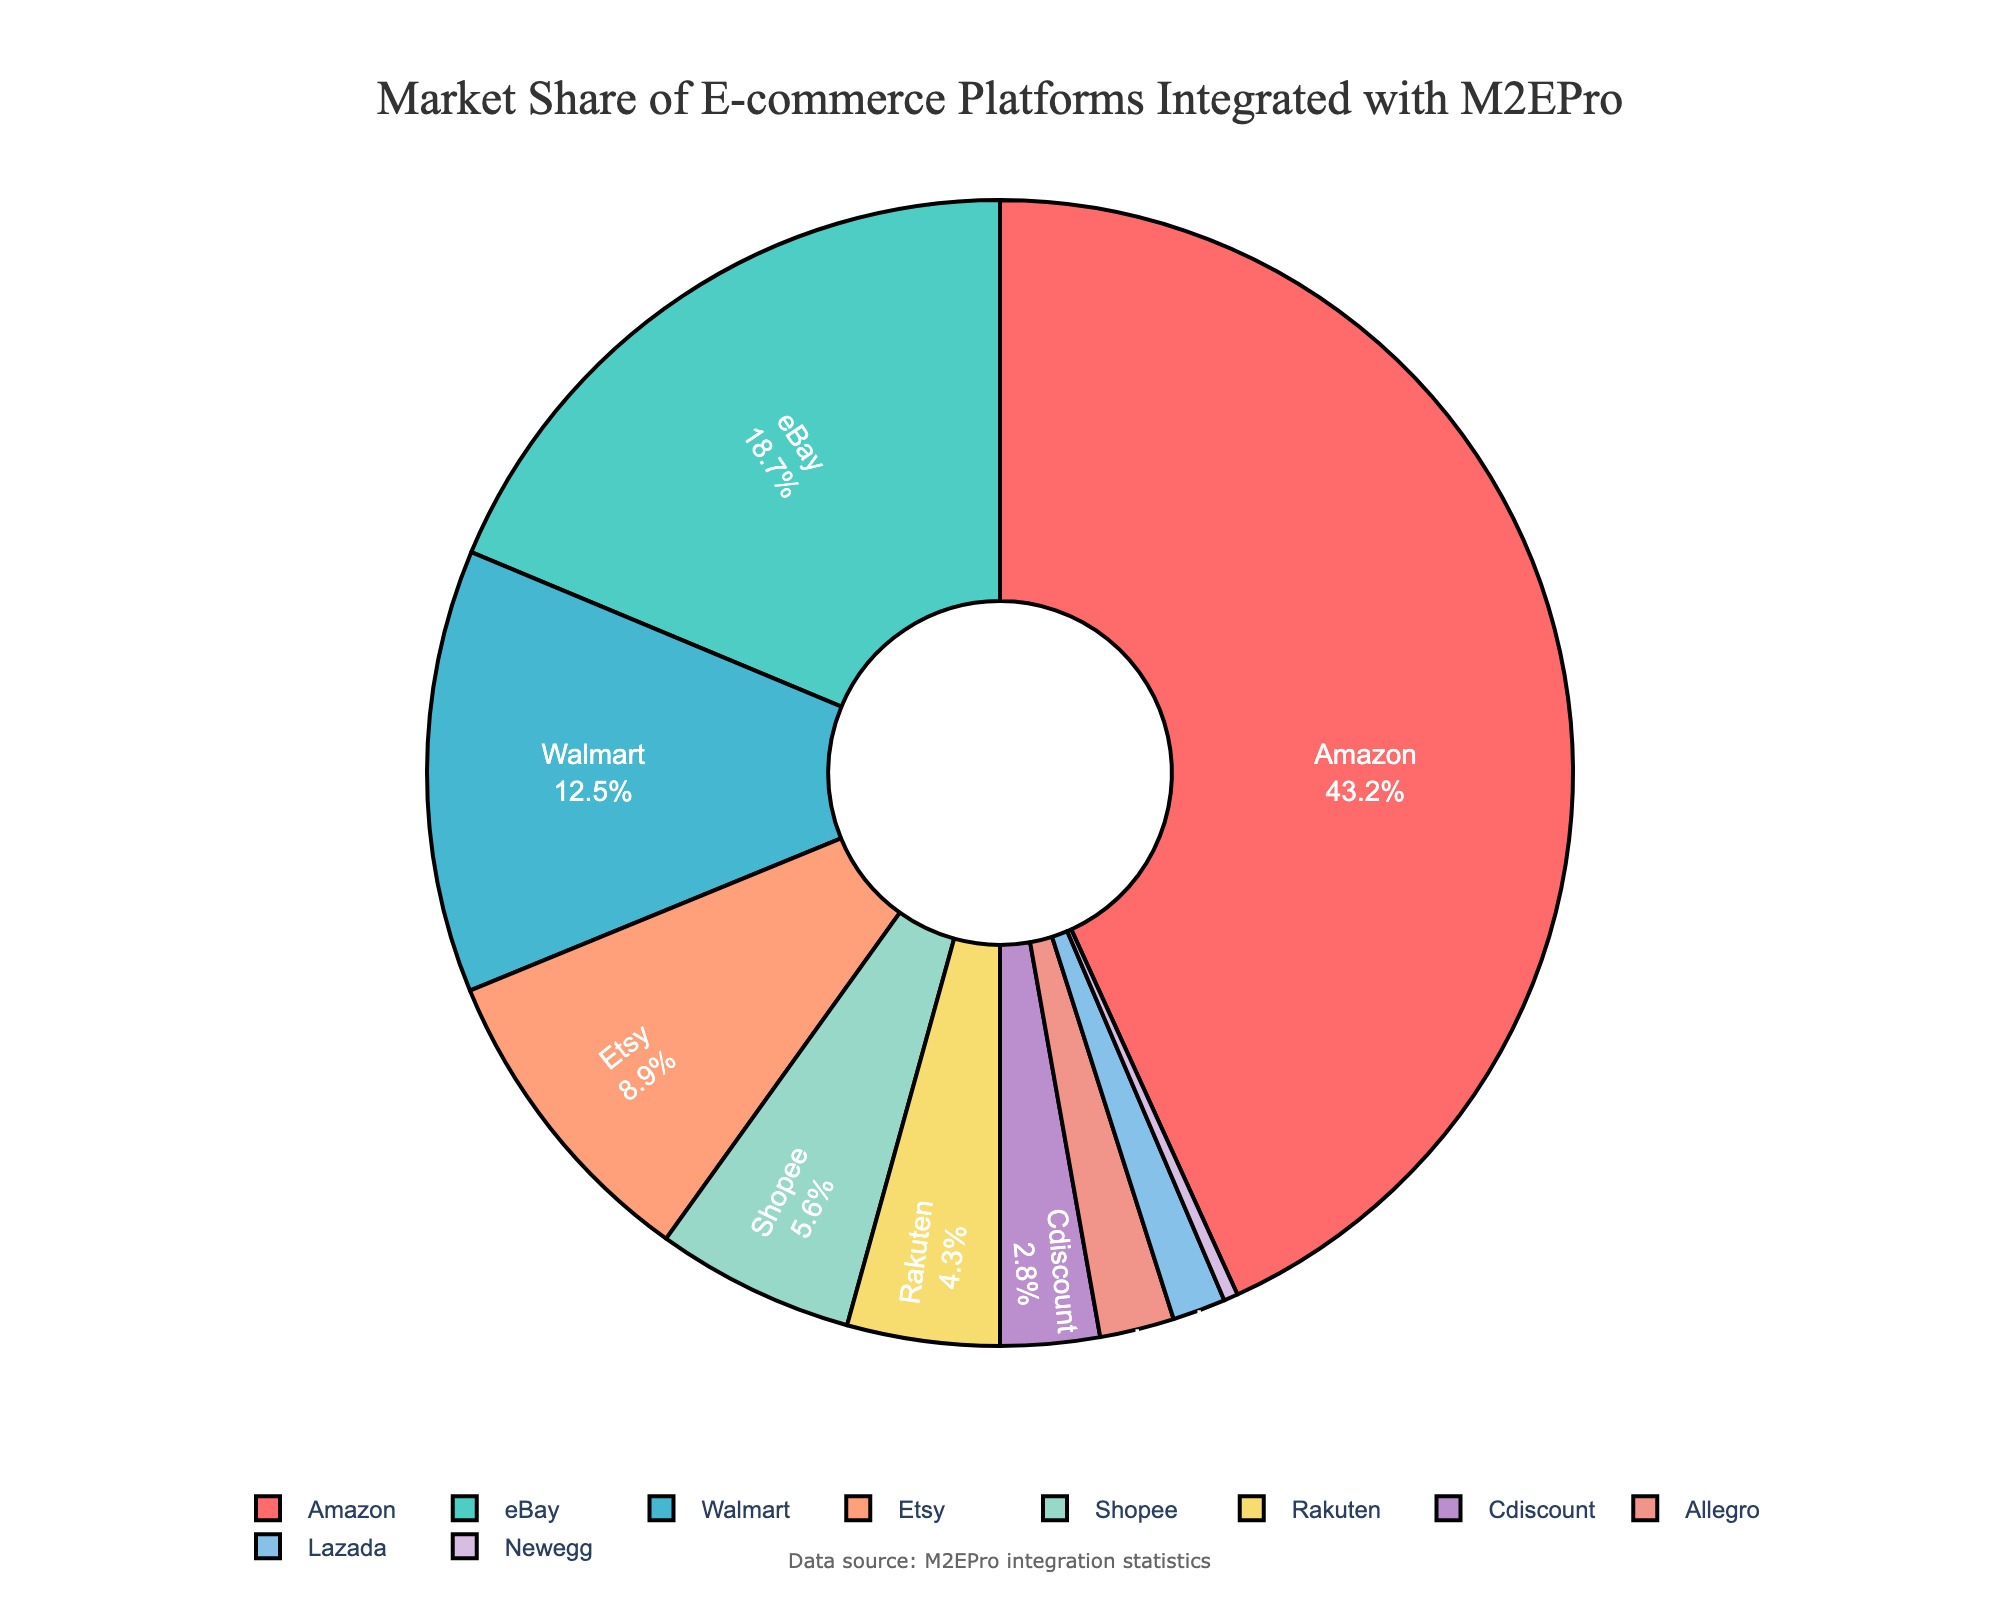What is the market share of Amazon? Refer to the pie chart segment labeled "Amazon". The slice appears to comprise 43.2% of the whole pie.
Answer: 43.2% Which e-commerce platform has the highest market share? Identify the largest slice in the pie chart, which is labeled "Amazon".
Answer: Amazon Compare the market shares of eBay and Walmart. Which one is greater and by how much? Locate the slices labeled "eBay" and "Walmart". eBay has 18.7%, and Walmart has 12.5%. Subtract Walmart's share from eBay's.
Answer: eBay by 6.2% What is the combined market share of Etsy, Shopee, and Rakuten? Locate and sum the percentages of the slices labeled "Etsy", "Shopee", and "Rakuten". (8.9% + 5.6% + 4.3% = 18.8%)
Answer: 18.8% What are the smallest and largest market shares, and which platforms are associated with them? Identify the largest and smallest slices in the pie chart. The largest is Amazon with 43.2%, and the smallest is Newegg with 0.4%.
Answer: Amazon (largest), Newegg (smallest) Which platform's market share is closest to 10%? Assess the values labeled for each slice to determine which one is near 10%. Etsy has 8.9%, which is the closest to 10%.
Answer: Etsy How does the market share of Shopee compare against that of Lazada? Check the slices labeled "Shopee" and "Lazada". Shopee has 5.6%, and Lazada has 1.5%.
Answer: Shopee is greater than Lazada Calculate the average market share of the platforms with more than 10% share. Platforms with more than 10% share are Amazon (43.2%), eBay (18.7%), and Walmart (12.5%). Compute the average: (43.2 + 18.7 + 12.5) / 3 = 24.8%.
Answer: 24.8% What is the total market share of platforms with less than 5%? Locate all slices representing less than 5%: Rakuten (4.3%), Cdiscount (2.8%), Allegro (2.1%), Lazada (1.5%), Newegg (0.4%). Sum them up: 4.3 + 2.8 + 2.1 + 1.5 + 0.4 = 11.1%.
Answer: 11.1% What can you infer from the size and color distribution of the pie chart? Larger slices indicate greater market share, and varied colors help in distinguishing different platforms. The predominance of Amazon’s sizable slice colored distinctly stands out, signifying its leading position.
Answer: Amazon dominates, others significantly less 